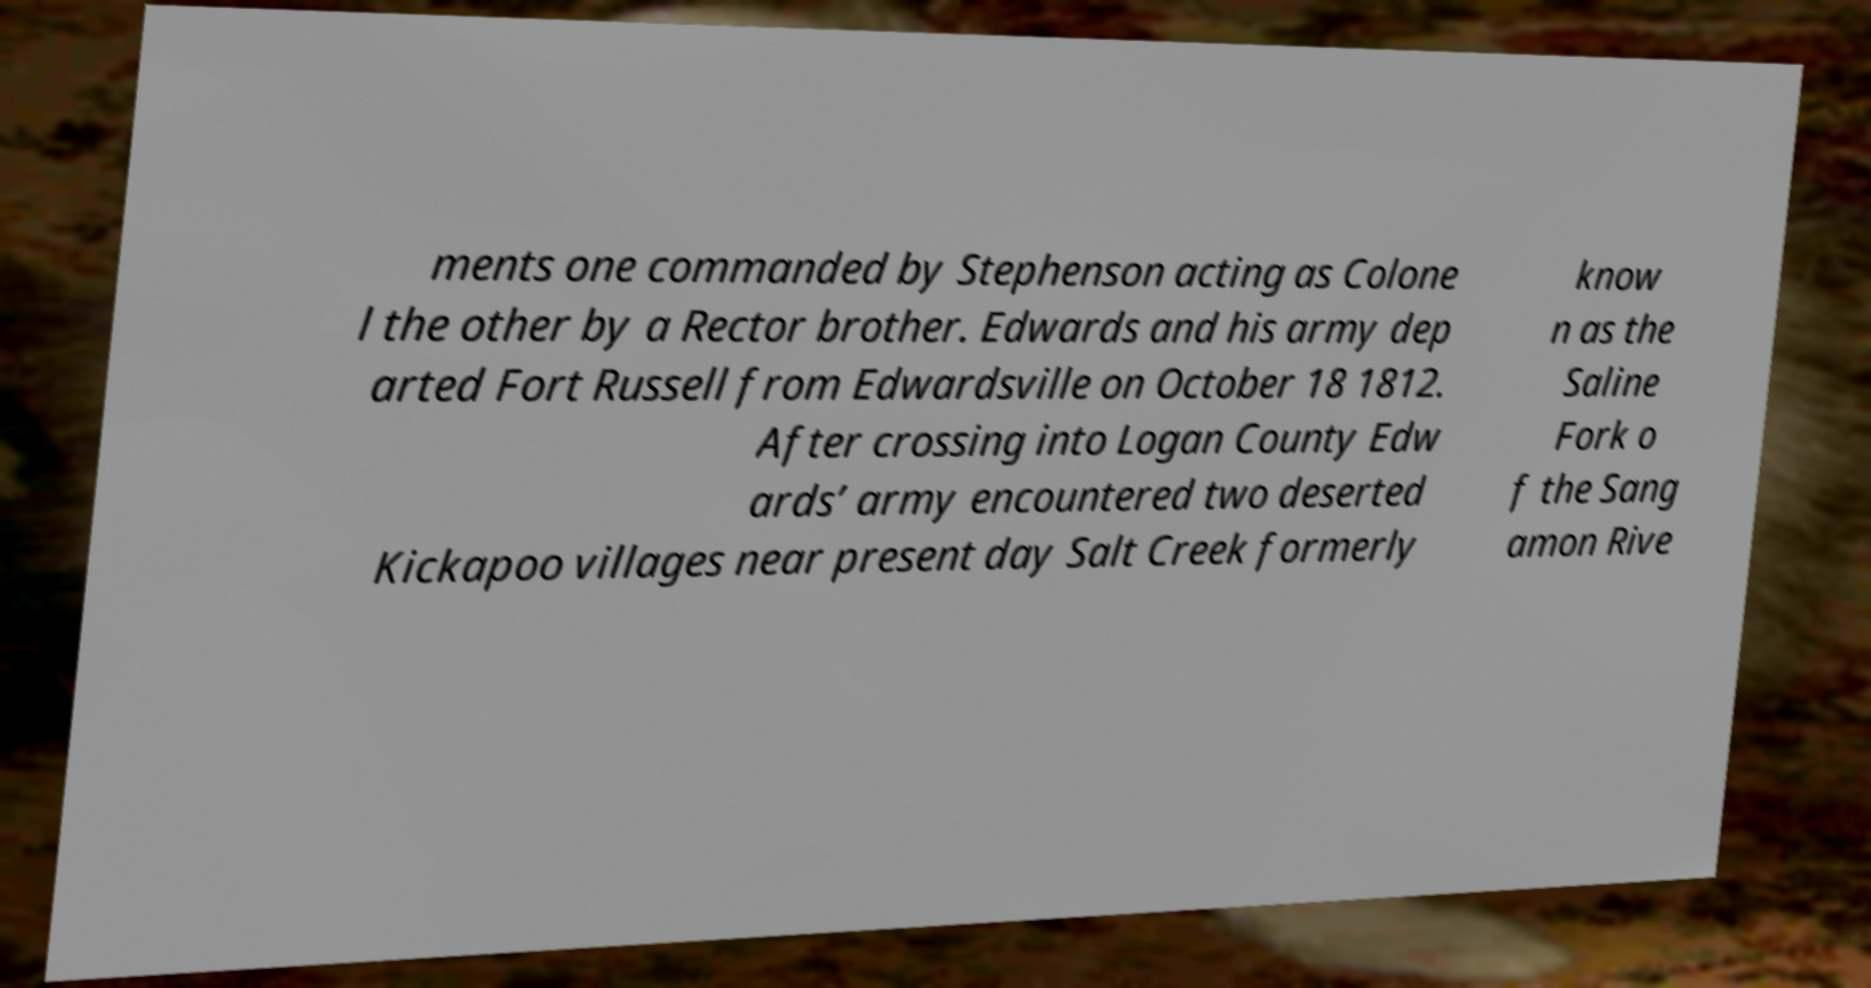Could you assist in decoding the text presented in this image and type it out clearly? ments one commanded by Stephenson acting as Colone l the other by a Rector brother. Edwards and his army dep arted Fort Russell from Edwardsville on October 18 1812. After crossing into Logan County Edw ards’ army encountered two deserted Kickapoo villages near present day Salt Creek formerly know n as the Saline Fork o f the Sang amon Rive 